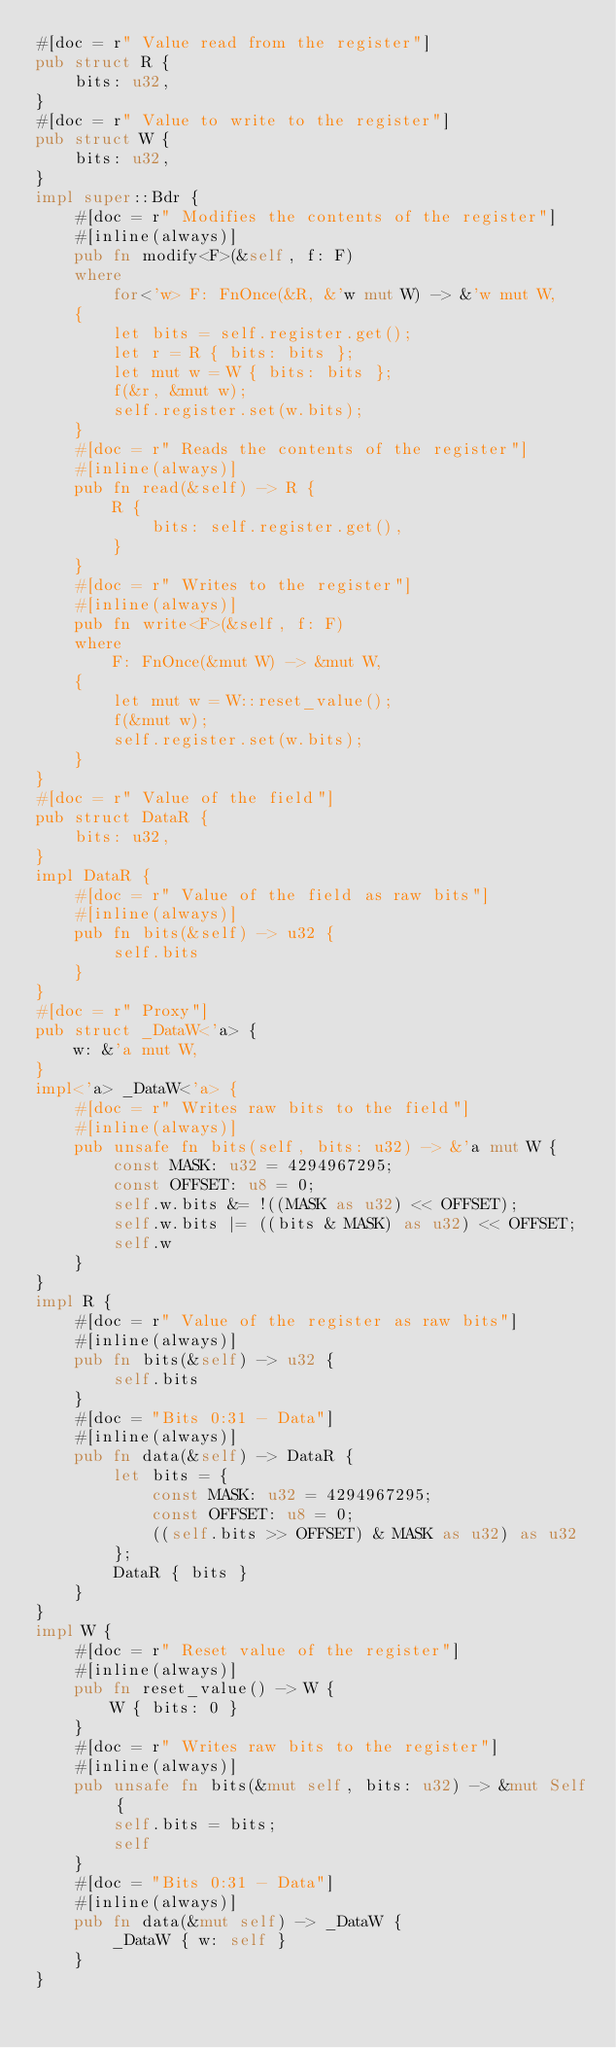Convert code to text. <code><loc_0><loc_0><loc_500><loc_500><_Rust_>#[doc = r" Value read from the register"]
pub struct R {
    bits: u32,
}
#[doc = r" Value to write to the register"]
pub struct W {
    bits: u32,
}
impl super::Bdr {
    #[doc = r" Modifies the contents of the register"]
    #[inline(always)]
    pub fn modify<F>(&self, f: F)
    where
        for<'w> F: FnOnce(&R, &'w mut W) -> &'w mut W,
    {
        let bits = self.register.get();
        let r = R { bits: bits };
        let mut w = W { bits: bits };
        f(&r, &mut w);
        self.register.set(w.bits);
    }
    #[doc = r" Reads the contents of the register"]
    #[inline(always)]
    pub fn read(&self) -> R {
        R {
            bits: self.register.get(),
        }
    }
    #[doc = r" Writes to the register"]
    #[inline(always)]
    pub fn write<F>(&self, f: F)
    where
        F: FnOnce(&mut W) -> &mut W,
    {
        let mut w = W::reset_value();
        f(&mut w);
        self.register.set(w.bits);
    }
}
#[doc = r" Value of the field"]
pub struct DataR {
    bits: u32,
}
impl DataR {
    #[doc = r" Value of the field as raw bits"]
    #[inline(always)]
    pub fn bits(&self) -> u32 {
        self.bits
    }
}
#[doc = r" Proxy"]
pub struct _DataW<'a> {
    w: &'a mut W,
}
impl<'a> _DataW<'a> {
    #[doc = r" Writes raw bits to the field"]
    #[inline(always)]
    pub unsafe fn bits(self, bits: u32) -> &'a mut W {
        const MASK: u32 = 4294967295;
        const OFFSET: u8 = 0;
        self.w.bits &= !((MASK as u32) << OFFSET);
        self.w.bits |= ((bits & MASK) as u32) << OFFSET;
        self.w
    }
}
impl R {
    #[doc = r" Value of the register as raw bits"]
    #[inline(always)]
    pub fn bits(&self) -> u32 {
        self.bits
    }
    #[doc = "Bits 0:31 - Data"]
    #[inline(always)]
    pub fn data(&self) -> DataR {
        let bits = {
            const MASK: u32 = 4294967295;
            const OFFSET: u8 = 0;
            ((self.bits >> OFFSET) & MASK as u32) as u32
        };
        DataR { bits }
    }
}
impl W {
    #[doc = r" Reset value of the register"]
    #[inline(always)]
    pub fn reset_value() -> W {
        W { bits: 0 }
    }
    #[doc = r" Writes raw bits to the register"]
    #[inline(always)]
    pub unsafe fn bits(&mut self, bits: u32) -> &mut Self {
        self.bits = bits;
        self
    }
    #[doc = "Bits 0:31 - Data"]
    #[inline(always)]
    pub fn data(&mut self) -> _DataW {
        _DataW { w: self }
    }
}
</code> 